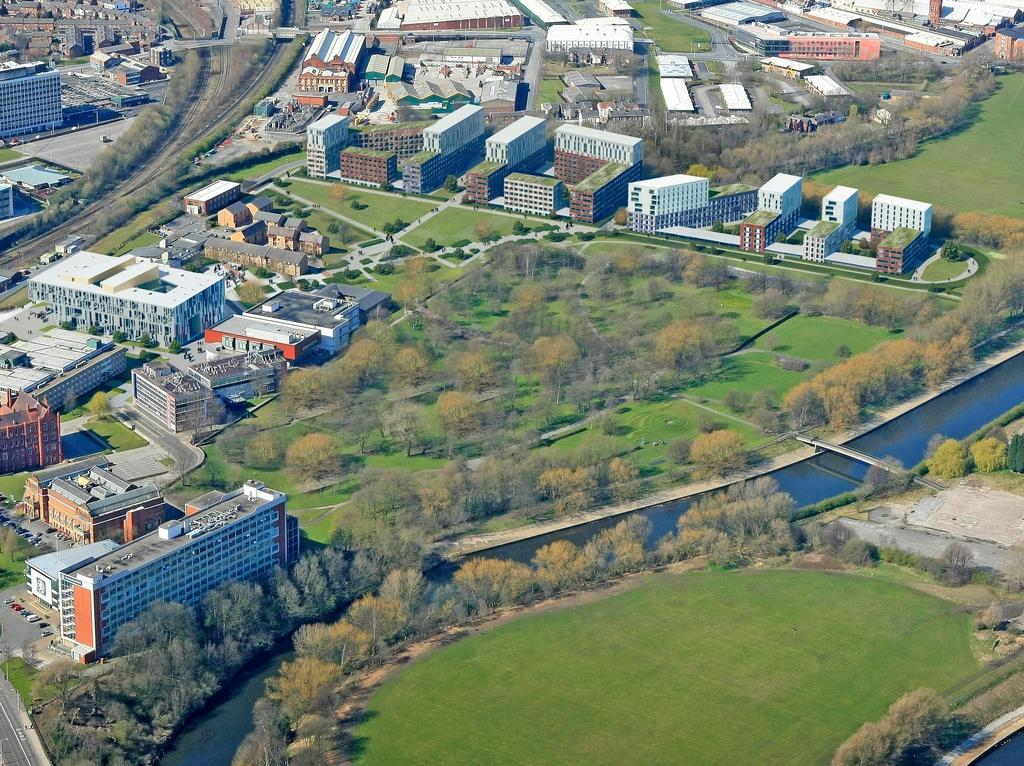What types of structures can be seen in the image? There are buildings and houses in the image. What natural elements are present in the image? There are trees, plants, grass, and water visible in the image. What man-made elements are present in the image? There are roads and a bridge in the image. How many cans are visible on the bridge in the image? There are no cans visible on the bridge in the image. What type of legs can be seen supporting the houses in the image? The houses in the image are not supported by legs; they are built on foundations. 